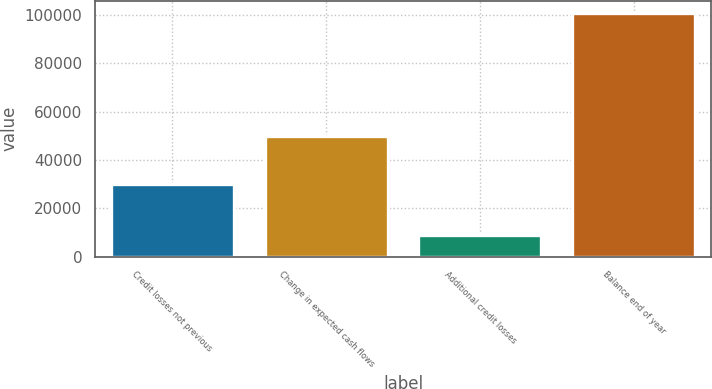<chart> <loc_0><loc_0><loc_500><loc_500><bar_chart><fcel>Credit losses not previous<fcel>Change in expected cash flows<fcel>Additional credit losses<fcel>Balance end of year<nl><fcel>30215<fcel>49802<fcel>8924<fcel>100838<nl></chart> 